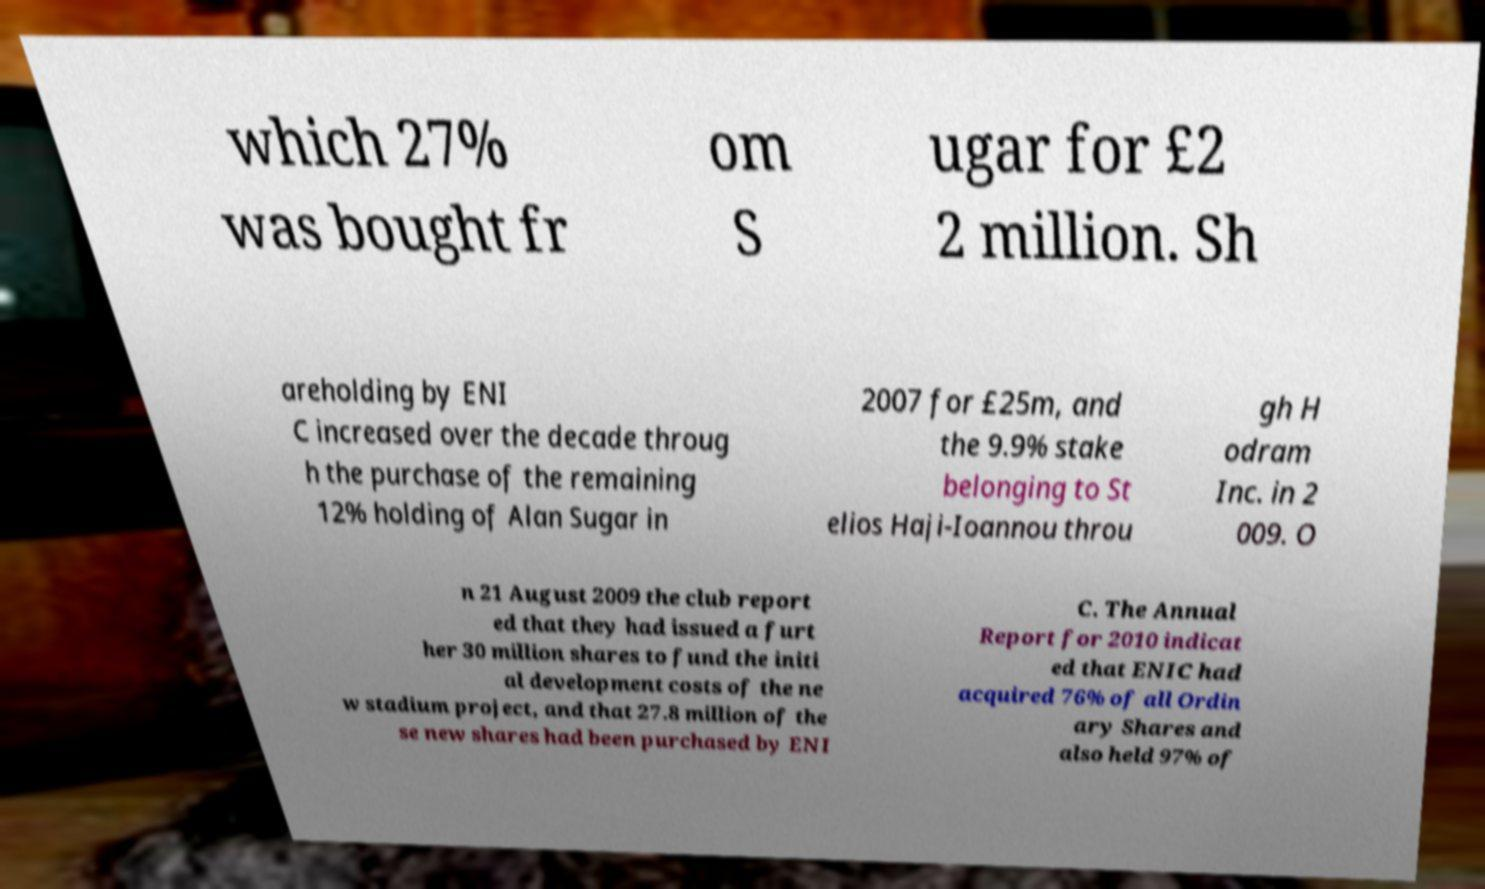Can you accurately transcribe the text from the provided image for me? which 27% was bought fr om S ugar for £2 2 million. Sh areholding by ENI C increased over the decade throug h the purchase of the remaining 12% holding of Alan Sugar in 2007 for £25m, and the 9.9% stake belonging to St elios Haji-Ioannou throu gh H odram Inc. in 2 009. O n 21 August 2009 the club report ed that they had issued a furt her 30 million shares to fund the initi al development costs of the ne w stadium project, and that 27.8 million of the se new shares had been purchased by ENI C. The Annual Report for 2010 indicat ed that ENIC had acquired 76% of all Ordin ary Shares and also held 97% of 